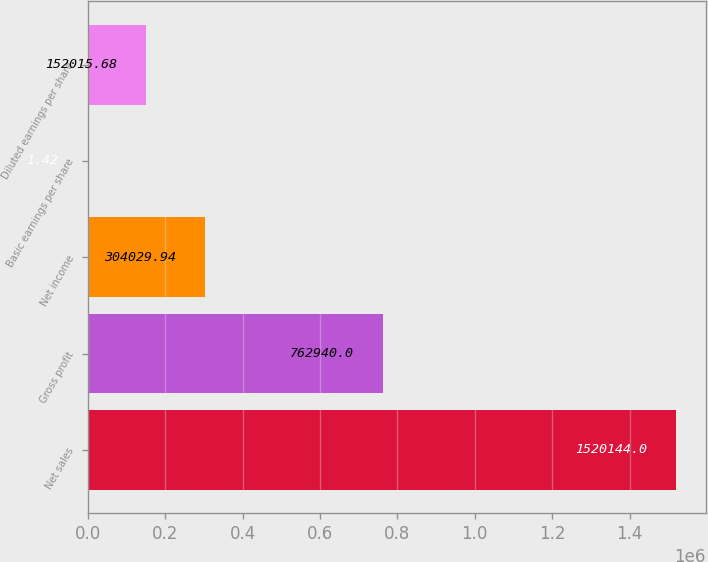<chart> <loc_0><loc_0><loc_500><loc_500><bar_chart><fcel>Net sales<fcel>Gross profit<fcel>Net income<fcel>Basic earnings per share<fcel>Diluted earnings per share<nl><fcel>1.52014e+06<fcel>762940<fcel>304030<fcel>1.42<fcel>152016<nl></chart> 